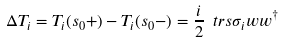Convert formula to latex. <formula><loc_0><loc_0><loc_500><loc_500>\Delta T _ { i } = T _ { i } ( s _ { 0 } + ) - T _ { i } ( s _ { 0 } - ) = \frac { i } { 2 } \ t r s { \sigma _ { i } w w ^ { \dagger } }</formula> 